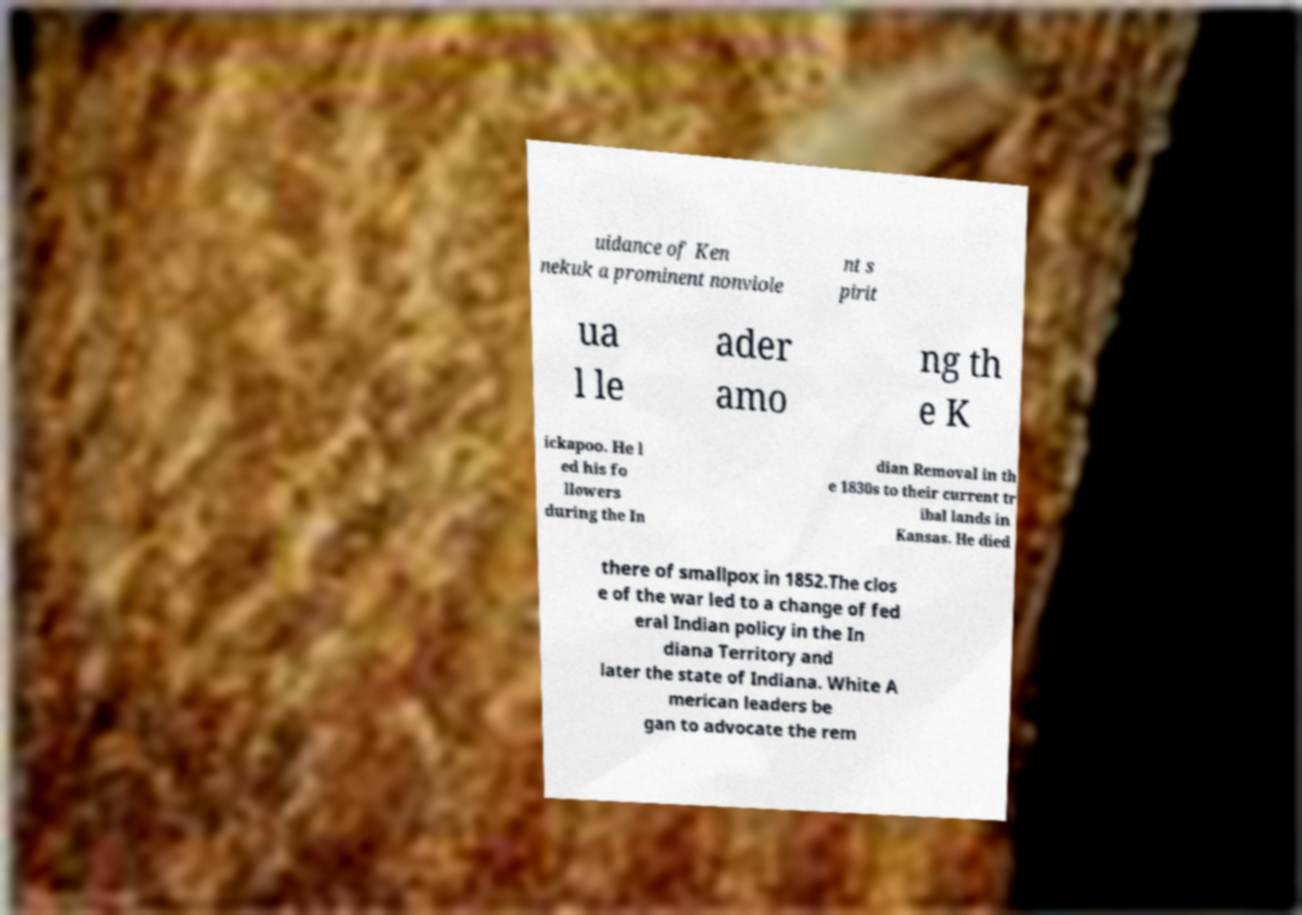For documentation purposes, I need the text within this image transcribed. Could you provide that? uidance of Ken nekuk a prominent nonviole nt s pirit ua l le ader amo ng th e K ickapoo. He l ed his fo llowers during the In dian Removal in th e 1830s to their current tr ibal lands in Kansas. He died there of smallpox in 1852.The clos e of the war led to a change of fed eral Indian policy in the In diana Territory and later the state of Indiana. White A merican leaders be gan to advocate the rem 